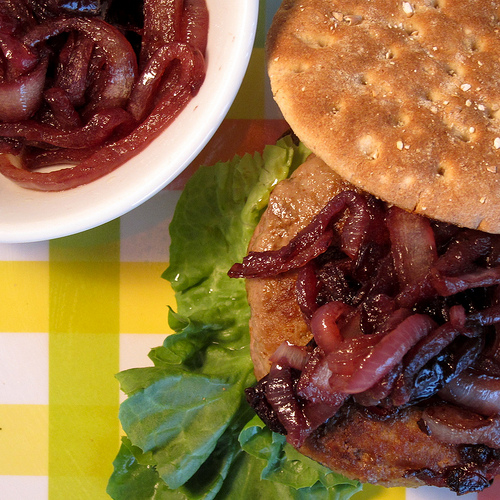<image>
Can you confirm if the lettuce is under the bread? Yes. The lettuce is positioned underneath the bread, with the bread above it in the vertical space. 